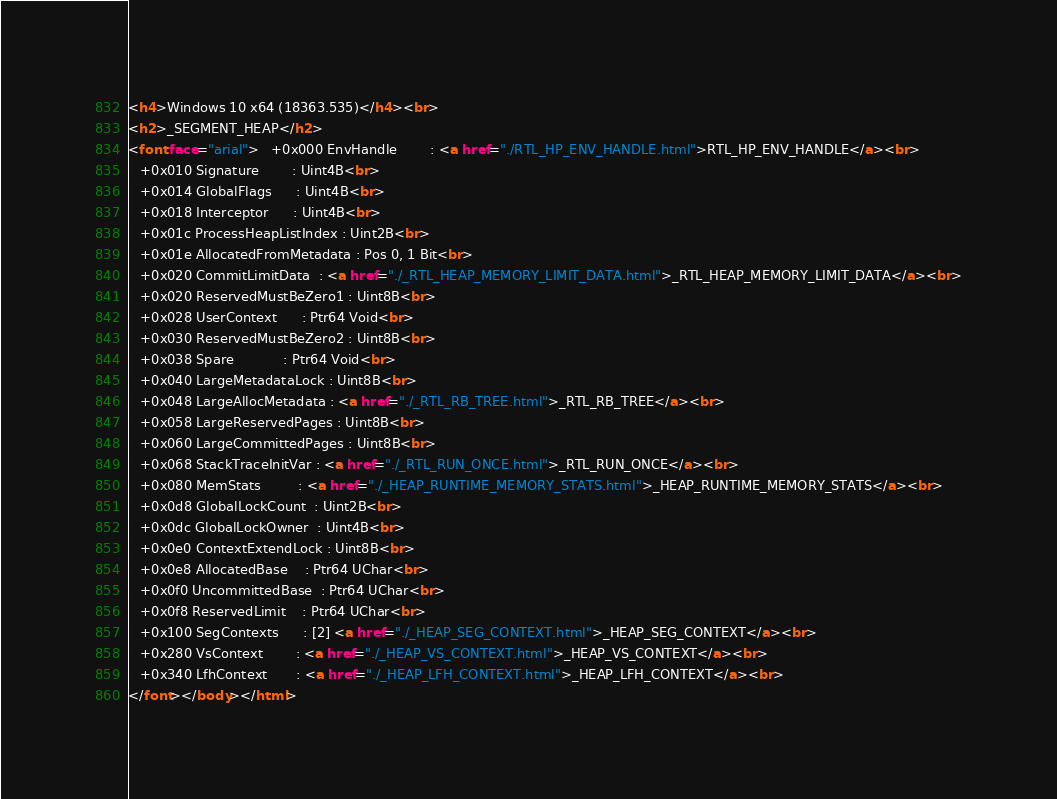Convert code to text. <code><loc_0><loc_0><loc_500><loc_500><_HTML_><h4>Windows 10 x64 (18363.535)</h4><br>
<h2>_SEGMENT_HEAP</h2>
<font face="arial">   +0x000 EnvHandle        : <a href="./RTL_HP_ENV_HANDLE.html">RTL_HP_ENV_HANDLE</a><br>
   +0x010 Signature        : Uint4B<br>
   +0x014 GlobalFlags      : Uint4B<br>
   +0x018 Interceptor      : Uint4B<br>
   +0x01c ProcessHeapListIndex : Uint2B<br>
   +0x01e AllocatedFromMetadata : Pos 0, 1 Bit<br>
   +0x020 CommitLimitData  : <a href="./_RTL_HEAP_MEMORY_LIMIT_DATA.html">_RTL_HEAP_MEMORY_LIMIT_DATA</a><br>
   +0x020 ReservedMustBeZero1 : Uint8B<br>
   +0x028 UserContext      : Ptr64 Void<br>
   +0x030 ReservedMustBeZero2 : Uint8B<br>
   +0x038 Spare            : Ptr64 Void<br>
   +0x040 LargeMetadataLock : Uint8B<br>
   +0x048 LargeAllocMetadata : <a href="./_RTL_RB_TREE.html">_RTL_RB_TREE</a><br>
   +0x058 LargeReservedPages : Uint8B<br>
   +0x060 LargeCommittedPages : Uint8B<br>
   +0x068 StackTraceInitVar : <a href="./_RTL_RUN_ONCE.html">_RTL_RUN_ONCE</a><br>
   +0x080 MemStats         : <a href="./_HEAP_RUNTIME_MEMORY_STATS.html">_HEAP_RUNTIME_MEMORY_STATS</a><br>
   +0x0d8 GlobalLockCount  : Uint2B<br>
   +0x0dc GlobalLockOwner  : Uint4B<br>
   +0x0e0 ContextExtendLock : Uint8B<br>
   +0x0e8 AllocatedBase    : Ptr64 UChar<br>
   +0x0f0 UncommittedBase  : Ptr64 UChar<br>
   +0x0f8 ReservedLimit    : Ptr64 UChar<br>
   +0x100 SegContexts      : [2] <a href="./_HEAP_SEG_CONTEXT.html">_HEAP_SEG_CONTEXT</a><br>
   +0x280 VsContext        : <a href="./_HEAP_VS_CONTEXT.html">_HEAP_VS_CONTEXT</a><br>
   +0x340 LfhContext       : <a href="./_HEAP_LFH_CONTEXT.html">_HEAP_LFH_CONTEXT</a><br>
</font></body></html></code> 